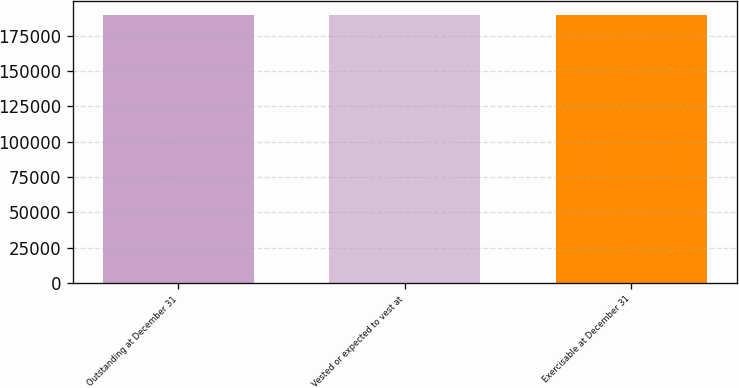Convert chart. <chart><loc_0><loc_0><loc_500><loc_500><bar_chart><fcel>Outstanding at December 31<fcel>Vested or expected to vest at<fcel>Exercisable at December 31<nl><fcel>190000<fcel>190000<fcel>190000<nl></chart> 